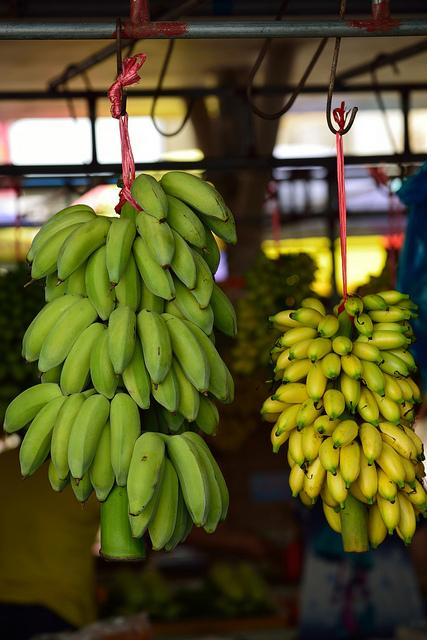Where are these items sold? bananas 